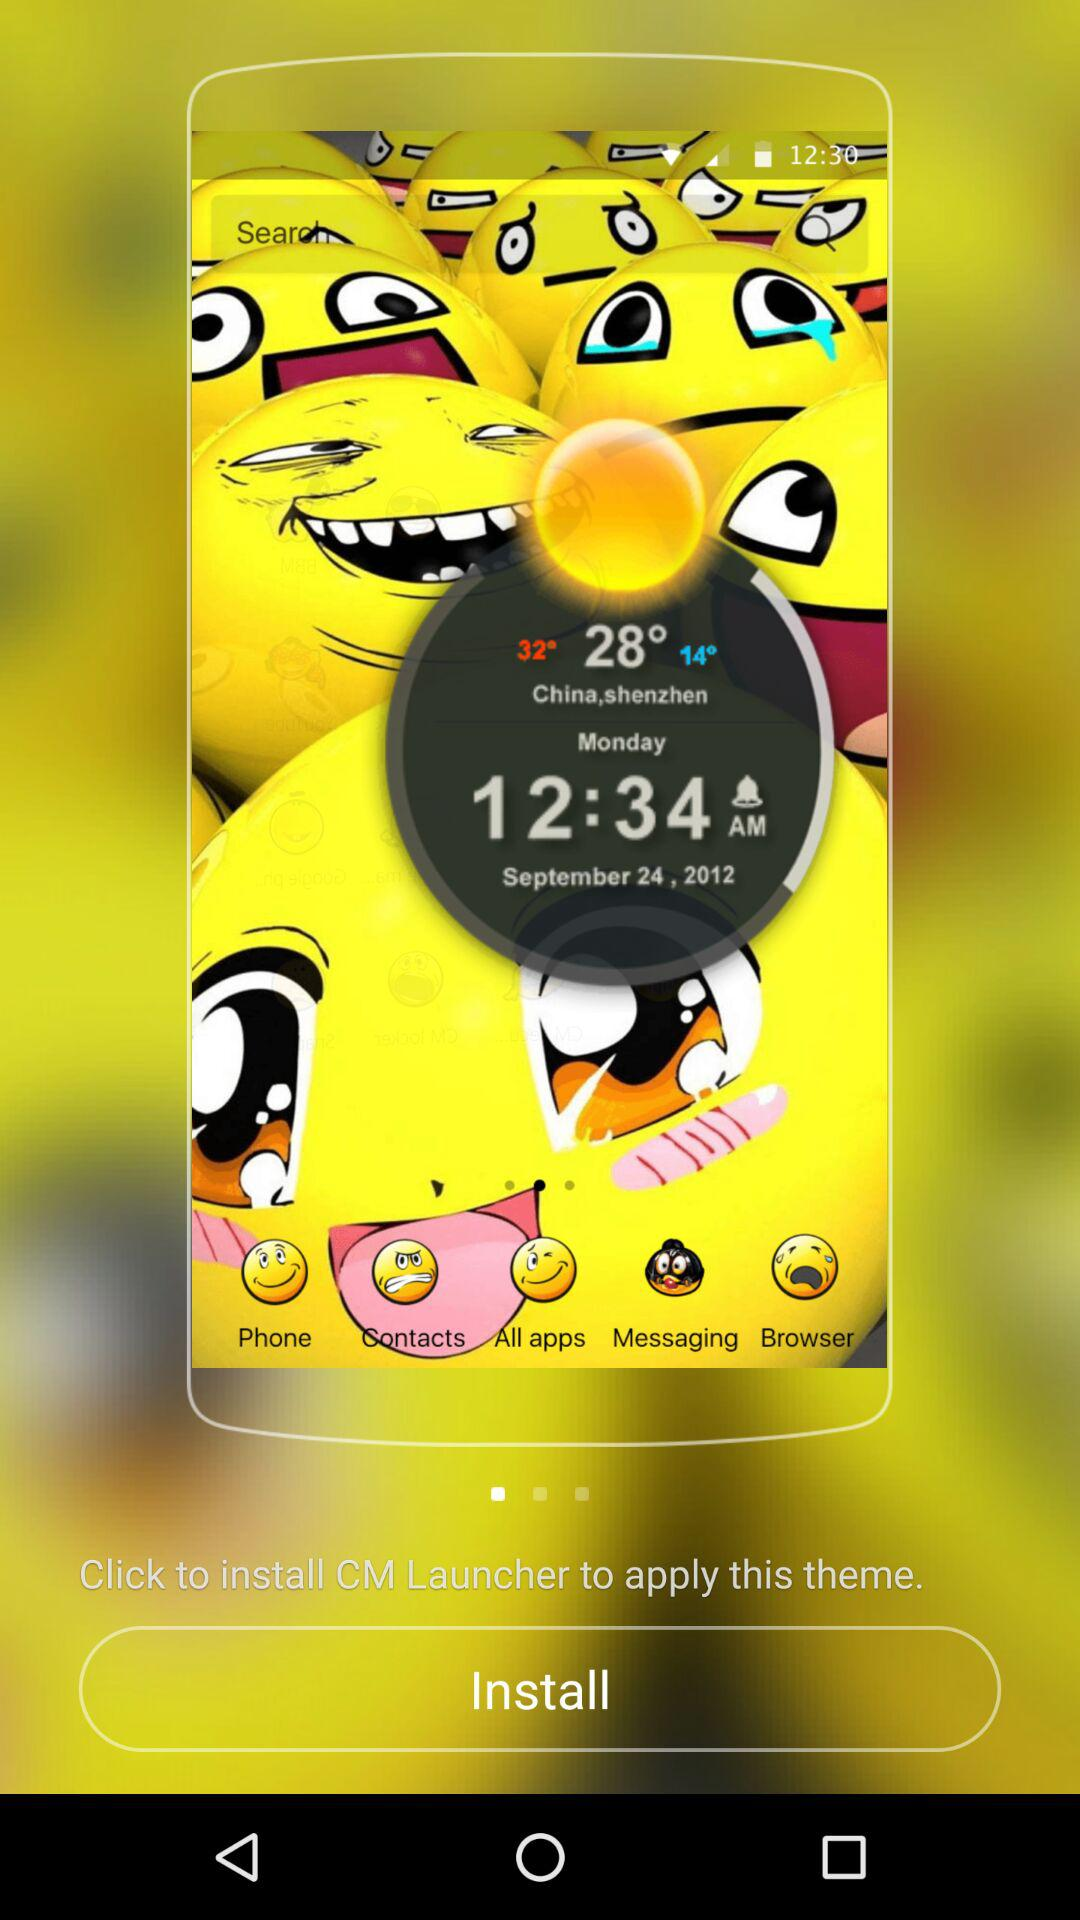What is the date? The date is Monday, September 24, 2012. 